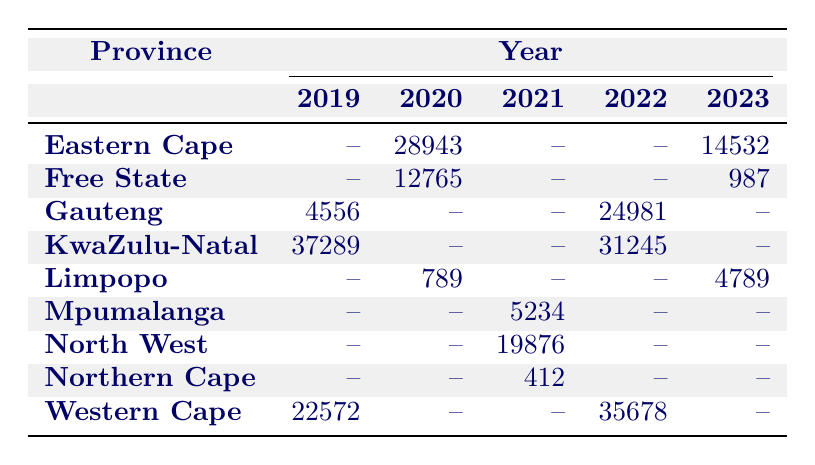What was the highest number of assault incidents reported in a single province in 2022? In 2022, the Western Cape reported 35,678 assault incidents, which is the highest among all provinces for that year.
Answer: 35678 Which province had the lowest number of incidents reported in 2023? The Free State had the lowest reported incidents in 2023 with only 987 carjacking incidents.
Answer: 987 How many total murder incidents were recorded in the Northern Cape over the five years? The Northern Cape recorded 412 murder incidents in 2021 and no other incidents in the other years. Thus, the total is 412.
Answer: 412 Did Gauteng report any drug-related incidents between 2019 and 2023? No, Gauteng did not report any drug-related incidents during these years, as the table does not show any entries for that crime type in Gauteng.
Answer: No What is the difference in robbery incidents reported in Gauteng between 2019 and 2022? In 2019, Gauteng had no robbery incidents reported, while in 2022, it reported 24,981 incidents, giving a difference of 24,981.
Answer: 24981 Which province reported more burglary incidents in 2022 than the previous year? KwaZulu-Natal reported 31,245 burglary incidents in 2022, which was an increase from zero incidents reported in 2020, indicating an increase for that type of crime.
Answer: Yes How many total incidents of sexual offences were reported across all provinces in 2021? In 2021, only Mpumalanga reported sexual offences with 5,234 incidents, hence the total is solely 5,234.
Answer: 5234 What is the trend of incidents reported in KwaZulu-Natal for the crime type of burglary from 2020 to 2022? The data shows that KwaZulu-Natal had no burglary incidents in 2020 and then increased to 31,245 incidents in 2022, indicating a rising trend.
Answer: Rising How many different crime types were reported in Limpopo between 2019 and 2023? Limpopo had data for carjacking in 2020, sexual offences in 2023, but no crime types listed for the other years. Therefore, only 2 different crime types were reported.
Answer: 2 